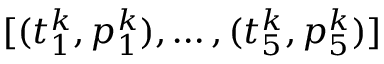Convert formula to latex. <formula><loc_0><loc_0><loc_500><loc_500>[ ( t _ { 1 } ^ { k } , p _ { 1 } ^ { k } ) , \dots , ( t _ { 5 } ^ { k } , p _ { 5 } ^ { k } ) ]</formula> 